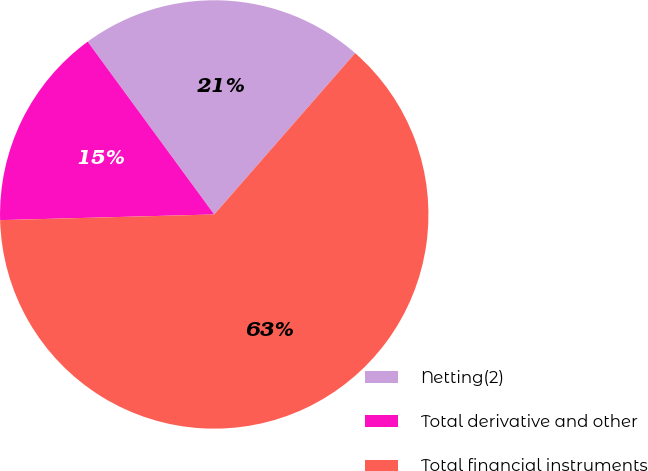<chart> <loc_0><loc_0><loc_500><loc_500><pie_chart><fcel>Netting(2)<fcel>Total derivative and other<fcel>Total financial instruments<nl><fcel>21.49%<fcel>15.36%<fcel>63.15%<nl></chart> 